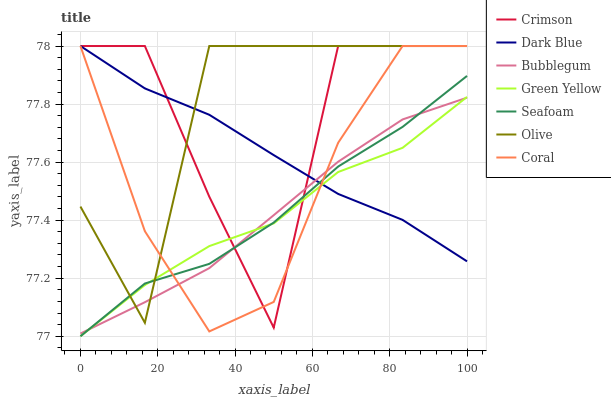Does Green Yellow have the minimum area under the curve?
Answer yes or no. Yes. Does Olive have the maximum area under the curve?
Answer yes or no. Yes. Does Coral have the minimum area under the curve?
Answer yes or no. No. Does Coral have the maximum area under the curve?
Answer yes or no. No. Is Bubblegum the smoothest?
Answer yes or no. Yes. Is Crimson the roughest?
Answer yes or no. Yes. Is Coral the smoothest?
Answer yes or no. No. Is Coral the roughest?
Answer yes or no. No. Does Coral have the lowest value?
Answer yes or no. No. Does Crimson have the highest value?
Answer yes or no. Yes. Does Seafoam have the highest value?
Answer yes or no. No. Does Green Yellow intersect Crimson?
Answer yes or no. Yes. Is Green Yellow less than Crimson?
Answer yes or no. No. Is Green Yellow greater than Crimson?
Answer yes or no. No. 